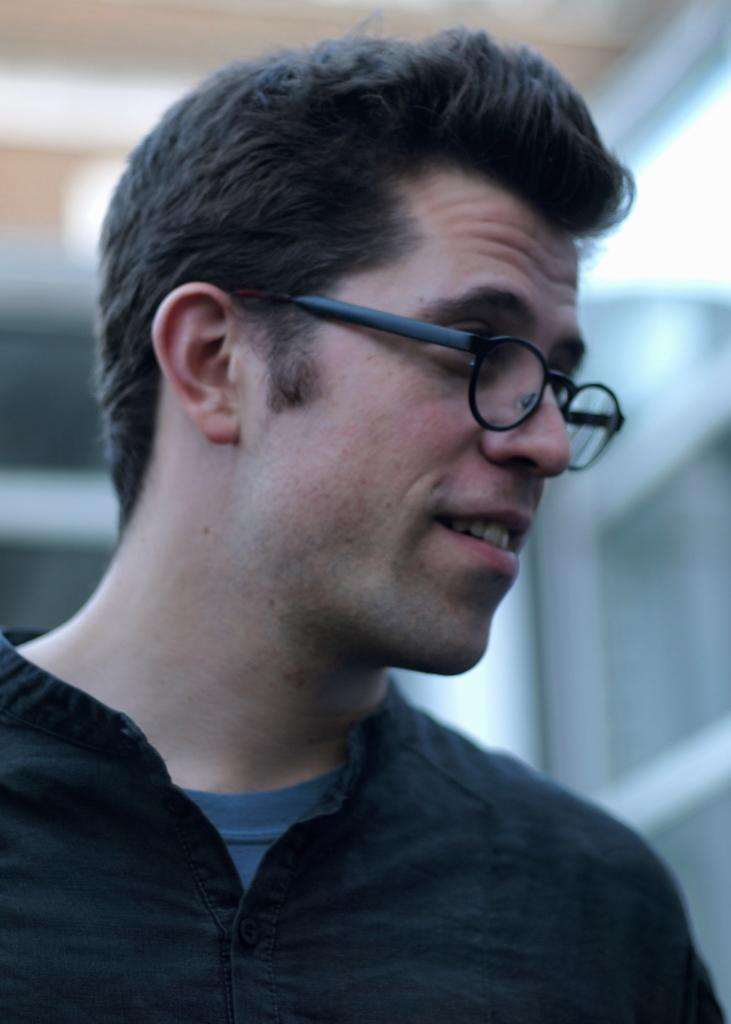What is the main subject of the image? There is a person in the image. What is the person wearing? The person is wearing a black color shirt. Are there any accessories visible on the person? Yes, the person is wearing spectacles. What is the person's facial expression or action? The person's mouth is open. How much wealth does the person in the image possess? There is no information about the person's wealth in the image. What type of cream is being applied to the person's face in the image? There is no cream being applied to the person's face in the image. 